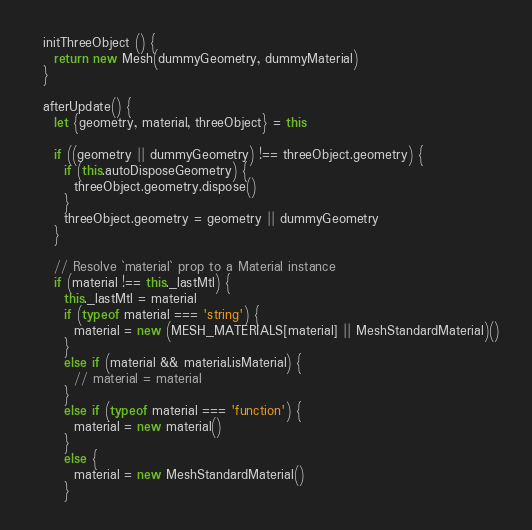<code> <loc_0><loc_0><loc_500><loc_500><_JavaScript_>
  initThreeObject () {
    return new Mesh(dummyGeometry, dummyMaterial)
  }

  afterUpdate() {
    let {geometry, material, threeObject} = this

    if ((geometry || dummyGeometry) !== threeObject.geometry) {
      if (this.autoDisposeGeometry) {
        threeObject.geometry.dispose()
      }
      threeObject.geometry = geometry || dummyGeometry
    }

    // Resolve `material` prop to a Material instance
    if (material !== this._lastMtl) {
      this._lastMtl = material
      if (typeof material === 'string') {
        material = new (MESH_MATERIALS[material] || MeshStandardMaterial)()
      }
      else if (material && material.isMaterial) {
        // material = material
      }
      else if (typeof material === 'function') {
        material = new material()
      }
      else {
        material = new MeshStandardMaterial()
      }</code> 